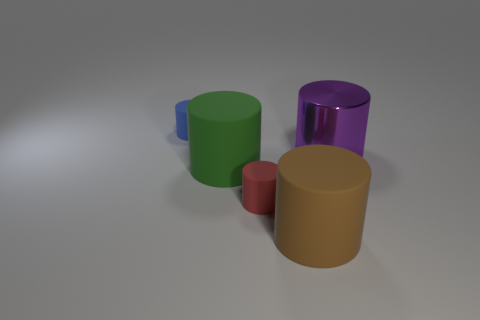Add 3 large blue shiny balls. How many objects exist? 8 Subtract all small red matte cylinders. How many cylinders are left? 4 Subtract all red cylinders. How many cylinders are left? 4 Subtract all blue cylinders. Subtract all yellow balls. How many cylinders are left? 4 Subtract all yellow spheres. How many gray cylinders are left? 0 Add 2 red cylinders. How many red cylinders are left? 3 Add 1 small blue cylinders. How many small blue cylinders exist? 2 Subtract 0 green blocks. How many objects are left? 5 Subtract 5 cylinders. How many cylinders are left? 0 Subtract all red cylinders. Subtract all green matte cylinders. How many objects are left? 3 